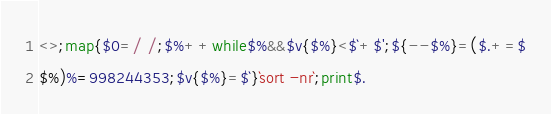<code> <loc_0><loc_0><loc_500><loc_500><_Perl_><>;map{$0=/ /;$%++while$%&&$v{$%}<$`+$';${--$%}=($.+=$
$%)%=998244353;$v{$%}=$`}`sort -nr`;print$.</code> 